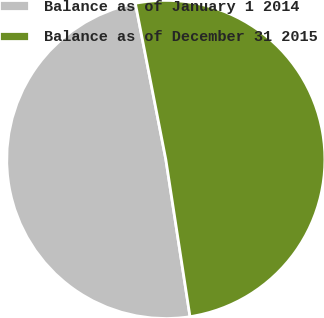Convert chart to OTSL. <chart><loc_0><loc_0><loc_500><loc_500><pie_chart><fcel>Balance as of January 1 2014<fcel>Balance as of December 31 2015<nl><fcel>49.36%<fcel>50.64%<nl></chart> 